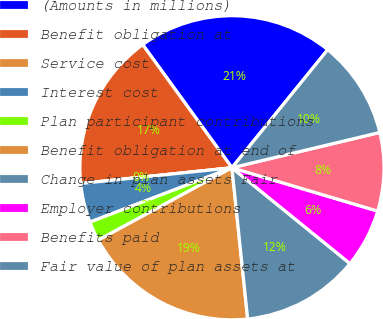<chart> <loc_0><loc_0><loc_500><loc_500><pie_chart><fcel>(Amounts in millions)<fcel>Benefit obligation at<fcel>Service cost<fcel>Interest cost<fcel>Plan participant contributions<fcel>Benefit obligation at end of<fcel>Change in plan assets Fair<fcel>Employer contributions<fcel>Benefits paid<fcel>Fair value of plan assets at<nl><fcel>20.83%<fcel>16.67%<fcel>0.0%<fcel>4.17%<fcel>2.08%<fcel>18.75%<fcel>12.5%<fcel>6.25%<fcel>8.33%<fcel>10.42%<nl></chart> 